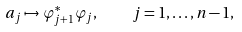<formula> <loc_0><loc_0><loc_500><loc_500>a _ { j } \mapsto \varphi _ { j + 1 } ^ { \ast } \varphi _ { j } , \quad j = 1 , \dots , n - 1 ,</formula> 